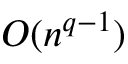<formula> <loc_0><loc_0><loc_500><loc_500>O ( n ^ { q - 1 } )</formula> 